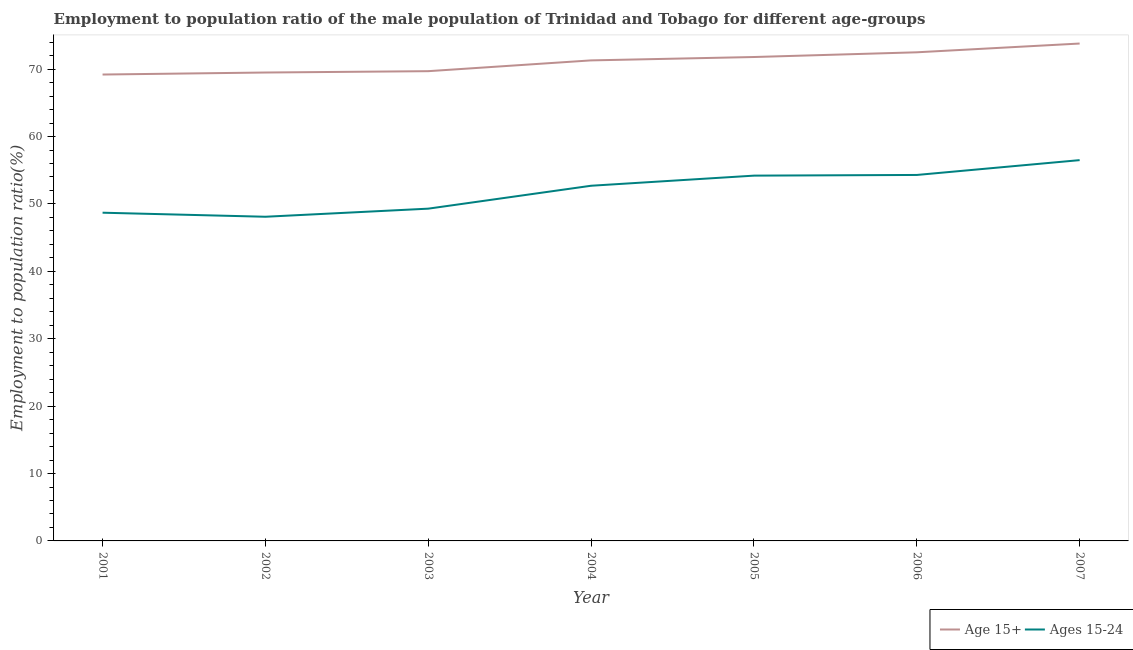How many different coloured lines are there?
Offer a terse response. 2. Is the number of lines equal to the number of legend labels?
Ensure brevity in your answer.  Yes. What is the employment to population ratio(age 15+) in 2002?
Make the answer very short. 69.5. Across all years, what is the maximum employment to population ratio(age 15-24)?
Your answer should be very brief. 56.5. Across all years, what is the minimum employment to population ratio(age 15+)?
Offer a terse response. 69.2. What is the total employment to population ratio(age 15+) in the graph?
Offer a very short reply. 497.8. What is the difference between the employment to population ratio(age 15-24) in 2002 and that in 2005?
Offer a very short reply. -6.1. What is the difference between the employment to population ratio(age 15+) in 2005 and the employment to population ratio(age 15-24) in 2003?
Provide a short and direct response. 22.5. What is the average employment to population ratio(age 15+) per year?
Offer a very short reply. 71.11. In the year 2002, what is the difference between the employment to population ratio(age 15+) and employment to population ratio(age 15-24)?
Give a very brief answer. 21.4. What is the ratio of the employment to population ratio(age 15+) in 2002 to that in 2006?
Your answer should be very brief. 0.96. Is the difference between the employment to population ratio(age 15-24) in 2001 and 2004 greater than the difference between the employment to population ratio(age 15+) in 2001 and 2004?
Make the answer very short. No. What is the difference between the highest and the second highest employment to population ratio(age 15-24)?
Your answer should be compact. 2.2. What is the difference between the highest and the lowest employment to population ratio(age 15+)?
Offer a very short reply. 4.6. In how many years, is the employment to population ratio(age 15+) greater than the average employment to population ratio(age 15+) taken over all years?
Your answer should be compact. 4. Is the sum of the employment to population ratio(age 15-24) in 2001 and 2007 greater than the maximum employment to population ratio(age 15+) across all years?
Provide a short and direct response. Yes. Does the employment to population ratio(age 15+) monotonically increase over the years?
Offer a terse response. Yes. Is the employment to population ratio(age 15+) strictly greater than the employment to population ratio(age 15-24) over the years?
Ensure brevity in your answer.  Yes. How many years are there in the graph?
Ensure brevity in your answer.  7. Are the values on the major ticks of Y-axis written in scientific E-notation?
Give a very brief answer. No. Where does the legend appear in the graph?
Offer a very short reply. Bottom right. How many legend labels are there?
Provide a short and direct response. 2. What is the title of the graph?
Your answer should be very brief. Employment to population ratio of the male population of Trinidad and Tobago for different age-groups. Does "Services" appear as one of the legend labels in the graph?
Provide a succinct answer. No. What is the label or title of the X-axis?
Provide a succinct answer. Year. What is the Employment to population ratio(%) of Age 15+ in 2001?
Your answer should be very brief. 69.2. What is the Employment to population ratio(%) of Ages 15-24 in 2001?
Make the answer very short. 48.7. What is the Employment to population ratio(%) of Age 15+ in 2002?
Make the answer very short. 69.5. What is the Employment to population ratio(%) in Ages 15-24 in 2002?
Your response must be concise. 48.1. What is the Employment to population ratio(%) in Age 15+ in 2003?
Make the answer very short. 69.7. What is the Employment to population ratio(%) in Ages 15-24 in 2003?
Offer a very short reply. 49.3. What is the Employment to population ratio(%) in Age 15+ in 2004?
Offer a terse response. 71.3. What is the Employment to population ratio(%) in Ages 15-24 in 2004?
Keep it short and to the point. 52.7. What is the Employment to population ratio(%) of Age 15+ in 2005?
Offer a terse response. 71.8. What is the Employment to population ratio(%) of Ages 15-24 in 2005?
Provide a succinct answer. 54.2. What is the Employment to population ratio(%) in Age 15+ in 2006?
Your response must be concise. 72.5. What is the Employment to population ratio(%) in Ages 15-24 in 2006?
Provide a short and direct response. 54.3. What is the Employment to population ratio(%) of Age 15+ in 2007?
Provide a short and direct response. 73.8. What is the Employment to population ratio(%) in Ages 15-24 in 2007?
Provide a short and direct response. 56.5. Across all years, what is the maximum Employment to population ratio(%) in Age 15+?
Your answer should be compact. 73.8. Across all years, what is the maximum Employment to population ratio(%) of Ages 15-24?
Keep it short and to the point. 56.5. Across all years, what is the minimum Employment to population ratio(%) in Age 15+?
Ensure brevity in your answer.  69.2. Across all years, what is the minimum Employment to population ratio(%) in Ages 15-24?
Give a very brief answer. 48.1. What is the total Employment to population ratio(%) of Age 15+ in the graph?
Your response must be concise. 497.8. What is the total Employment to population ratio(%) in Ages 15-24 in the graph?
Your answer should be very brief. 363.8. What is the difference between the Employment to population ratio(%) in Ages 15-24 in 2001 and that in 2002?
Offer a very short reply. 0.6. What is the difference between the Employment to population ratio(%) of Ages 15-24 in 2001 and that in 2006?
Your answer should be compact. -5.6. What is the difference between the Employment to population ratio(%) in Ages 15-24 in 2001 and that in 2007?
Ensure brevity in your answer.  -7.8. What is the difference between the Employment to population ratio(%) of Age 15+ in 2002 and that in 2004?
Give a very brief answer. -1.8. What is the difference between the Employment to population ratio(%) in Ages 15-24 in 2002 and that in 2004?
Your response must be concise. -4.6. What is the difference between the Employment to population ratio(%) in Age 15+ in 2002 and that in 2005?
Provide a short and direct response. -2.3. What is the difference between the Employment to population ratio(%) of Age 15+ in 2002 and that in 2006?
Your answer should be compact. -3. What is the difference between the Employment to population ratio(%) of Ages 15-24 in 2002 and that in 2006?
Offer a terse response. -6.2. What is the difference between the Employment to population ratio(%) in Age 15+ in 2002 and that in 2007?
Keep it short and to the point. -4.3. What is the difference between the Employment to population ratio(%) in Age 15+ in 2003 and that in 2004?
Offer a terse response. -1.6. What is the difference between the Employment to population ratio(%) in Age 15+ in 2003 and that in 2006?
Ensure brevity in your answer.  -2.8. What is the difference between the Employment to population ratio(%) in Ages 15-24 in 2003 and that in 2007?
Keep it short and to the point. -7.2. What is the difference between the Employment to population ratio(%) of Age 15+ in 2004 and that in 2005?
Give a very brief answer. -0.5. What is the difference between the Employment to population ratio(%) in Ages 15-24 in 2004 and that in 2005?
Offer a terse response. -1.5. What is the difference between the Employment to population ratio(%) of Age 15+ in 2004 and that in 2006?
Offer a very short reply. -1.2. What is the difference between the Employment to population ratio(%) in Age 15+ in 2004 and that in 2007?
Offer a terse response. -2.5. What is the difference between the Employment to population ratio(%) of Ages 15-24 in 2004 and that in 2007?
Give a very brief answer. -3.8. What is the difference between the Employment to population ratio(%) in Ages 15-24 in 2005 and that in 2006?
Offer a very short reply. -0.1. What is the difference between the Employment to population ratio(%) in Age 15+ in 2005 and that in 2007?
Provide a short and direct response. -2. What is the difference between the Employment to population ratio(%) of Age 15+ in 2006 and that in 2007?
Your answer should be compact. -1.3. What is the difference between the Employment to population ratio(%) in Age 15+ in 2001 and the Employment to population ratio(%) in Ages 15-24 in 2002?
Give a very brief answer. 21.1. What is the difference between the Employment to population ratio(%) in Age 15+ in 2002 and the Employment to population ratio(%) in Ages 15-24 in 2003?
Your answer should be very brief. 20.2. What is the difference between the Employment to population ratio(%) in Age 15+ in 2002 and the Employment to population ratio(%) in Ages 15-24 in 2004?
Offer a terse response. 16.8. What is the difference between the Employment to population ratio(%) of Age 15+ in 2002 and the Employment to population ratio(%) of Ages 15-24 in 2005?
Offer a very short reply. 15.3. What is the difference between the Employment to population ratio(%) of Age 15+ in 2002 and the Employment to population ratio(%) of Ages 15-24 in 2006?
Give a very brief answer. 15.2. What is the difference between the Employment to population ratio(%) in Age 15+ in 2002 and the Employment to population ratio(%) in Ages 15-24 in 2007?
Ensure brevity in your answer.  13. What is the difference between the Employment to population ratio(%) of Age 15+ in 2003 and the Employment to population ratio(%) of Ages 15-24 in 2004?
Your answer should be compact. 17. What is the difference between the Employment to population ratio(%) of Age 15+ in 2003 and the Employment to population ratio(%) of Ages 15-24 in 2005?
Your answer should be very brief. 15.5. What is the difference between the Employment to population ratio(%) of Age 15+ in 2003 and the Employment to population ratio(%) of Ages 15-24 in 2007?
Keep it short and to the point. 13.2. What is the difference between the Employment to population ratio(%) of Age 15+ in 2004 and the Employment to population ratio(%) of Ages 15-24 in 2006?
Your answer should be compact. 17. What is the difference between the Employment to population ratio(%) in Age 15+ in 2004 and the Employment to population ratio(%) in Ages 15-24 in 2007?
Provide a succinct answer. 14.8. What is the difference between the Employment to population ratio(%) in Age 15+ in 2005 and the Employment to population ratio(%) in Ages 15-24 in 2006?
Your answer should be compact. 17.5. What is the average Employment to population ratio(%) of Age 15+ per year?
Offer a very short reply. 71.11. What is the average Employment to population ratio(%) in Ages 15-24 per year?
Give a very brief answer. 51.97. In the year 2001, what is the difference between the Employment to population ratio(%) in Age 15+ and Employment to population ratio(%) in Ages 15-24?
Your response must be concise. 20.5. In the year 2002, what is the difference between the Employment to population ratio(%) of Age 15+ and Employment to population ratio(%) of Ages 15-24?
Offer a terse response. 21.4. In the year 2003, what is the difference between the Employment to population ratio(%) in Age 15+ and Employment to population ratio(%) in Ages 15-24?
Offer a very short reply. 20.4. In the year 2004, what is the difference between the Employment to population ratio(%) of Age 15+ and Employment to population ratio(%) of Ages 15-24?
Make the answer very short. 18.6. What is the ratio of the Employment to population ratio(%) in Age 15+ in 2001 to that in 2002?
Offer a terse response. 1. What is the ratio of the Employment to population ratio(%) of Ages 15-24 in 2001 to that in 2002?
Provide a short and direct response. 1.01. What is the ratio of the Employment to population ratio(%) in Age 15+ in 2001 to that in 2003?
Offer a terse response. 0.99. What is the ratio of the Employment to population ratio(%) in Ages 15-24 in 2001 to that in 2003?
Keep it short and to the point. 0.99. What is the ratio of the Employment to population ratio(%) in Age 15+ in 2001 to that in 2004?
Your response must be concise. 0.97. What is the ratio of the Employment to population ratio(%) of Ages 15-24 in 2001 to that in 2004?
Offer a very short reply. 0.92. What is the ratio of the Employment to population ratio(%) in Age 15+ in 2001 to that in 2005?
Your response must be concise. 0.96. What is the ratio of the Employment to population ratio(%) in Ages 15-24 in 2001 to that in 2005?
Your answer should be very brief. 0.9. What is the ratio of the Employment to population ratio(%) in Age 15+ in 2001 to that in 2006?
Your answer should be compact. 0.95. What is the ratio of the Employment to population ratio(%) in Ages 15-24 in 2001 to that in 2006?
Offer a terse response. 0.9. What is the ratio of the Employment to population ratio(%) of Age 15+ in 2001 to that in 2007?
Ensure brevity in your answer.  0.94. What is the ratio of the Employment to population ratio(%) in Ages 15-24 in 2001 to that in 2007?
Ensure brevity in your answer.  0.86. What is the ratio of the Employment to population ratio(%) of Ages 15-24 in 2002 to that in 2003?
Your answer should be compact. 0.98. What is the ratio of the Employment to population ratio(%) in Age 15+ in 2002 to that in 2004?
Your answer should be compact. 0.97. What is the ratio of the Employment to population ratio(%) of Ages 15-24 in 2002 to that in 2004?
Offer a terse response. 0.91. What is the ratio of the Employment to population ratio(%) of Age 15+ in 2002 to that in 2005?
Your answer should be compact. 0.97. What is the ratio of the Employment to population ratio(%) of Ages 15-24 in 2002 to that in 2005?
Keep it short and to the point. 0.89. What is the ratio of the Employment to population ratio(%) in Age 15+ in 2002 to that in 2006?
Make the answer very short. 0.96. What is the ratio of the Employment to population ratio(%) in Ages 15-24 in 2002 to that in 2006?
Give a very brief answer. 0.89. What is the ratio of the Employment to population ratio(%) in Age 15+ in 2002 to that in 2007?
Keep it short and to the point. 0.94. What is the ratio of the Employment to population ratio(%) in Ages 15-24 in 2002 to that in 2007?
Offer a very short reply. 0.85. What is the ratio of the Employment to population ratio(%) in Age 15+ in 2003 to that in 2004?
Make the answer very short. 0.98. What is the ratio of the Employment to population ratio(%) of Ages 15-24 in 2003 to that in 2004?
Offer a very short reply. 0.94. What is the ratio of the Employment to population ratio(%) in Age 15+ in 2003 to that in 2005?
Give a very brief answer. 0.97. What is the ratio of the Employment to population ratio(%) of Ages 15-24 in 2003 to that in 2005?
Ensure brevity in your answer.  0.91. What is the ratio of the Employment to population ratio(%) of Age 15+ in 2003 to that in 2006?
Your answer should be compact. 0.96. What is the ratio of the Employment to population ratio(%) of Ages 15-24 in 2003 to that in 2006?
Make the answer very short. 0.91. What is the ratio of the Employment to population ratio(%) of Age 15+ in 2003 to that in 2007?
Your response must be concise. 0.94. What is the ratio of the Employment to population ratio(%) of Ages 15-24 in 2003 to that in 2007?
Your answer should be very brief. 0.87. What is the ratio of the Employment to population ratio(%) in Age 15+ in 2004 to that in 2005?
Provide a succinct answer. 0.99. What is the ratio of the Employment to population ratio(%) of Ages 15-24 in 2004 to that in 2005?
Make the answer very short. 0.97. What is the ratio of the Employment to population ratio(%) in Age 15+ in 2004 to that in 2006?
Offer a terse response. 0.98. What is the ratio of the Employment to population ratio(%) of Ages 15-24 in 2004 to that in 2006?
Your answer should be very brief. 0.97. What is the ratio of the Employment to population ratio(%) in Age 15+ in 2004 to that in 2007?
Your response must be concise. 0.97. What is the ratio of the Employment to population ratio(%) in Ages 15-24 in 2004 to that in 2007?
Your response must be concise. 0.93. What is the ratio of the Employment to population ratio(%) of Age 15+ in 2005 to that in 2006?
Your answer should be very brief. 0.99. What is the ratio of the Employment to population ratio(%) in Ages 15-24 in 2005 to that in 2006?
Keep it short and to the point. 1. What is the ratio of the Employment to population ratio(%) of Age 15+ in 2005 to that in 2007?
Provide a succinct answer. 0.97. What is the ratio of the Employment to population ratio(%) in Ages 15-24 in 2005 to that in 2007?
Provide a short and direct response. 0.96. What is the ratio of the Employment to population ratio(%) in Age 15+ in 2006 to that in 2007?
Provide a succinct answer. 0.98. What is the ratio of the Employment to population ratio(%) of Ages 15-24 in 2006 to that in 2007?
Offer a very short reply. 0.96. What is the difference between the highest and the second highest Employment to population ratio(%) of Ages 15-24?
Offer a terse response. 2.2. What is the difference between the highest and the lowest Employment to population ratio(%) in Age 15+?
Your answer should be very brief. 4.6. What is the difference between the highest and the lowest Employment to population ratio(%) of Ages 15-24?
Keep it short and to the point. 8.4. 